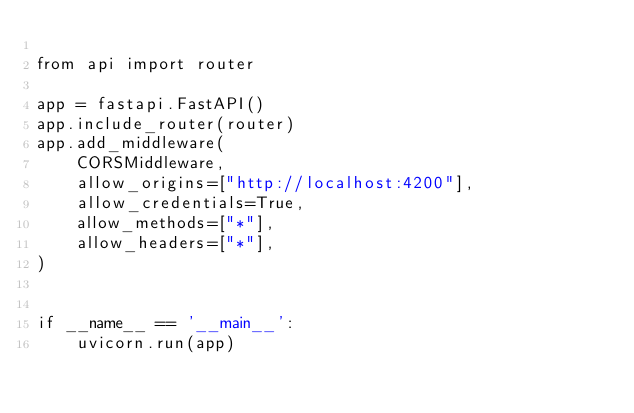<code> <loc_0><loc_0><loc_500><loc_500><_Python_>
from api import router

app = fastapi.FastAPI()
app.include_router(router)
app.add_middleware(
    CORSMiddleware,
    allow_origins=["http://localhost:4200"],
    allow_credentials=True,
    allow_methods=["*"],
    allow_headers=["*"],
)


if __name__ == '__main__':
    uvicorn.run(app)
</code> 